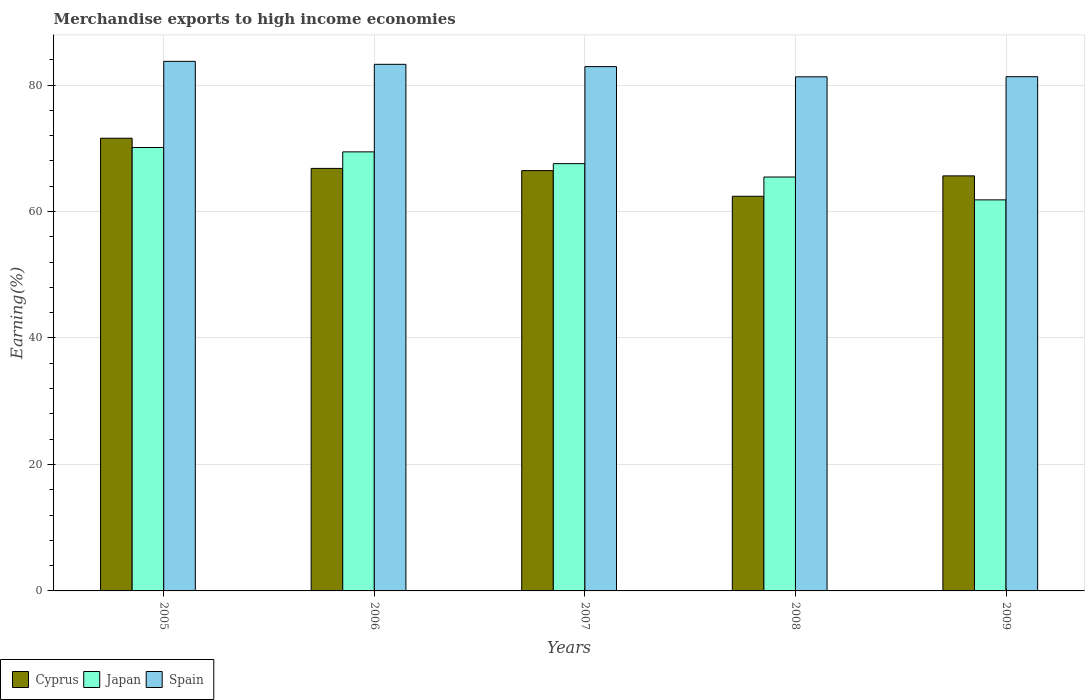How many different coloured bars are there?
Keep it short and to the point. 3. How many groups of bars are there?
Provide a short and direct response. 5. Are the number of bars per tick equal to the number of legend labels?
Ensure brevity in your answer.  Yes. Are the number of bars on each tick of the X-axis equal?
Offer a very short reply. Yes. How many bars are there on the 1st tick from the left?
Your answer should be very brief. 3. What is the label of the 2nd group of bars from the left?
Offer a terse response. 2006. What is the percentage of amount earned from merchandise exports in Spain in 2007?
Make the answer very short. 82.91. Across all years, what is the maximum percentage of amount earned from merchandise exports in Spain?
Provide a short and direct response. 83.74. Across all years, what is the minimum percentage of amount earned from merchandise exports in Cyprus?
Offer a very short reply. 62.4. What is the total percentage of amount earned from merchandise exports in Cyprus in the graph?
Make the answer very short. 332.9. What is the difference between the percentage of amount earned from merchandise exports in Japan in 2007 and that in 2008?
Provide a succinct answer. 2.12. What is the difference between the percentage of amount earned from merchandise exports in Cyprus in 2008 and the percentage of amount earned from merchandise exports in Japan in 2007?
Your answer should be compact. -5.16. What is the average percentage of amount earned from merchandise exports in Cyprus per year?
Give a very brief answer. 66.58. In the year 2009, what is the difference between the percentage of amount earned from merchandise exports in Japan and percentage of amount earned from merchandise exports in Spain?
Offer a terse response. -19.48. What is the ratio of the percentage of amount earned from merchandise exports in Cyprus in 2008 to that in 2009?
Your answer should be compact. 0.95. Is the difference between the percentage of amount earned from merchandise exports in Japan in 2008 and 2009 greater than the difference between the percentage of amount earned from merchandise exports in Spain in 2008 and 2009?
Ensure brevity in your answer.  Yes. What is the difference between the highest and the second highest percentage of amount earned from merchandise exports in Cyprus?
Your response must be concise. 4.77. What is the difference between the highest and the lowest percentage of amount earned from merchandise exports in Japan?
Keep it short and to the point. 8.28. In how many years, is the percentage of amount earned from merchandise exports in Spain greater than the average percentage of amount earned from merchandise exports in Spain taken over all years?
Your answer should be compact. 3. What does the 1st bar from the left in 2009 represents?
Offer a terse response. Cyprus. Is it the case that in every year, the sum of the percentage of amount earned from merchandise exports in Japan and percentage of amount earned from merchandise exports in Cyprus is greater than the percentage of amount earned from merchandise exports in Spain?
Offer a very short reply. Yes. How many bars are there?
Make the answer very short. 15. Are all the bars in the graph horizontal?
Provide a succinct answer. No. How many years are there in the graph?
Give a very brief answer. 5. What is the difference between two consecutive major ticks on the Y-axis?
Keep it short and to the point. 20. Are the values on the major ticks of Y-axis written in scientific E-notation?
Give a very brief answer. No. Does the graph contain any zero values?
Offer a terse response. No. Does the graph contain grids?
Make the answer very short. Yes. Where does the legend appear in the graph?
Provide a succinct answer. Bottom left. How are the legend labels stacked?
Your answer should be compact. Horizontal. What is the title of the graph?
Keep it short and to the point. Merchandise exports to high income economies. What is the label or title of the Y-axis?
Make the answer very short. Earning(%). What is the Earning(%) of Cyprus in 2005?
Provide a short and direct response. 71.59. What is the Earning(%) of Japan in 2005?
Provide a succinct answer. 70.12. What is the Earning(%) in Spain in 2005?
Your answer should be compact. 83.74. What is the Earning(%) of Cyprus in 2006?
Ensure brevity in your answer.  66.81. What is the Earning(%) of Japan in 2006?
Your answer should be compact. 69.43. What is the Earning(%) of Spain in 2006?
Ensure brevity in your answer.  83.27. What is the Earning(%) in Cyprus in 2007?
Give a very brief answer. 66.46. What is the Earning(%) in Japan in 2007?
Make the answer very short. 67.57. What is the Earning(%) in Spain in 2007?
Offer a very short reply. 82.91. What is the Earning(%) in Cyprus in 2008?
Your response must be concise. 62.4. What is the Earning(%) of Japan in 2008?
Provide a succinct answer. 65.45. What is the Earning(%) in Spain in 2008?
Ensure brevity in your answer.  81.3. What is the Earning(%) in Cyprus in 2009?
Your answer should be compact. 65.63. What is the Earning(%) in Japan in 2009?
Keep it short and to the point. 61.84. What is the Earning(%) of Spain in 2009?
Make the answer very short. 81.31. Across all years, what is the maximum Earning(%) in Cyprus?
Offer a terse response. 71.59. Across all years, what is the maximum Earning(%) of Japan?
Your response must be concise. 70.12. Across all years, what is the maximum Earning(%) in Spain?
Ensure brevity in your answer.  83.74. Across all years, what is the minimum Earning(%) of Cyprus?
Make the answer very short. 62.4. Across all years, what is the minimum Earning(%) of Japan?
Offer a terse response. 61.84. Across all years, what is the minimum Earning(%) in Spain?
Provide a short and direct response. 81.3. What is the total Earning(%) in Cyprus in the graph?
Keep it short and to the point. 332.9. What is the total Earning(%) in Japan in the graph?
Offer a very short reply. 334.4. What is the total Earning(%) of Spain in the graph?
Offer a terse response. 412.53. What is the difference between the Earning(%) of Cyprus in 2005 and that in 2006?
Your response must be concise. 4.77. What is the difference between the Earning(%) of Japan in 2005 and that in 2006?
Your response must be concise. 0.69. What is the difference between the Earning(%) of Spain in 2005 and that in 2006?
Your response must be concise. 0.47. What is the difference between the Earning(%) of Cyprus in 2005 and that in 2007?
Provide a succinct answer. 5.12. What is the difference between the Earning(%) in Japan in 2005 and that in 2007?
Offer a terse response. 2.55. What is the difference between the Earning(%) in Spain in 2005 and that in 2007?
Your answer should be compact. 0.83. What is the difference between the Earning(%) in Cyprus in 2005 and that in 2008?
Provide a short and direct response. 9.18. What is the difference between the Earning(%) of Japan in 2005 and that in 2008?
Make the answer very short. 4.67. What is the difference between the Earning(%) of Spain in 2005 and that in 2008?
Give a very brief answer. 2.44. What is the difference between the Earning(%) of Cyprus in 2005 and that in 2009?
Your response must be concise. 5.96. What is the difference between the Earning(%) of Japan in 2005 and that in 2009?
Keep it short and to the point. 8.28. What is the difference between the Earning(%) of Spain in 2005 and that in 2009?
Offer a terse response. 2.43. What is the difference between the Earning(%) in Cyprus in 2006 and that in 2007?
Your answer should be very brief. 0.35. What is the difference between the Earning(%) of Japan in 2006 and that in 2007?
Offer a very short reply. 1.86. What is the difference between the Earning(%) of Spain in 2006 and that in 2007?
Offer a terse response. 0.36. What is the difference between the Earning(%) of Cyprus in 2006 and that in 2008?
Make the answer very short. 4.41. What is the difference between the Earning(%) in Japan in 2006 and that in 2008?
Provide a short and direct response. 3.98. What is the difference between the Earning(%) in Spain in 2006 and that in 2008?
Ensure brevity in your answer.  1.98. What is the difference between the Earning(%) in Cyprus in 2006 and that in 2009?
Your response must be concise. 1.18. What is the difference between the Earning(%) in Japan in 2006 and that in 2009?
Offer a terse response. 7.59. What is the difference between the Earning(%) in Spain in 2006 and that in 2009?
Your response must be concise. 1.96. What is the difference between the Earning(%) in Cyprus in 2007 and that in 2008?
Provide a short and direct response. 4.06. What is the difference between the Earning(%) in Japan in 2007 and that in 2008?
Your answer should be very brief. 2.12. What is the difference between the Earning(%) of Spain in 2007 and that in 2008?
Keep it short and to the point. 1.61. What is the difference between the Earning(%) of Cyprus in 2007 and that in 2009?
Provide a succinct answer. 0.83. What is the difference between the Earning(%) in Japan in 2007 and that in 2009?
Your answer should be compact. 5.73. What is the difference between the Earning(%) of Spain in 2007 and that in 2009?
Your response must be concise. 1.59. What is the difference between the Earning(%) of Cyprus in 2008 and that in 2009?
Give a very brief answer. -3.23. What is the difference between the Earning(%) in Japan in 2008 and that in 2009?
Offer a terse response. 3.61. What is the difference between the Earning(%) in Spain in 2008 and that in 2009?
Make the answer very short. -0.02. What is the difference between the Earning(%) of Cyprus in 2005 and the Earning(%) of Japan in 2006?
Ensure brevity in your answer.  2.16. What is the difference between the Earning(%) in Cyprus in 2005 and the Earning(%) in Spain in 2006?
Your response must be concise. -11.69. What is the difference between the Earning(%) in Japan in 2005 and the Earning(%) in Spain in 2006?
Offer a very short reply. -13.15. What is the difference between the Earning(%) in Cyprus in 2005 and the Earning(%) in Japan in 2007?
Your answer should be compact. 4.02. What is the difference between the Earning(%) in Cyprus in 2005 and the Earning(%) in Spain in 2007?
Provide a succinct answer. -11.32. What is the difference between the Earning(%) in Japan in 2005 and the Earning(%) in Spain in 2007?
Keep it short and to the point. -12.79. What is the difference between the Earning(%) of Cyprus in 2005 and the Earning(%) of Japan in 2008?
Your answer should be compact. 6.14. What is the difference between the Earning(%) of Cyprus in 2005 and the Earning(%) of Spain in 2008?
Give a very brief answer. -9.71. What is the difference between the Earning(%) of Japan in 2005 and the Earning(%) of Spain in 2008?
Provide a short and direct response. -11.18. What is the difference between the Earning(%) in Cyprus in 2005 and the Earning(%) in Japan in 2009?
Offer a very short reply. 9.75. What is the difference between the Earning(%) in Cyprus in 2005 and the Earning(%) in Spain in 2009?
Your answer should be compact. -9.73. What is the difference between the Earning(%) of Japan in 2005 and the Earning(%) of Spain in 2009?
Provide a short and direct response. -11.2. What is the difference between the Earning(%) in Cyprus in 2006 and the Earning(%) in Japan in 2007?
Provide a short and direct response. -0.75. What is the difference between the Earning(%) in Cyprus in 2006 and the Earning(%) in Spain in 2007?
Offer a terse response. -16.09. What is the difference between the Earning(%) in Japan in 2006 and the Earning(%) in Spain in 2007?
Offer a terse response. -13.48. What is the difference between the Earning(%) of Cyprus in 2006 and the Earning(%) of Japan in 2008?
Offer a very short reply. 1.37. What is the difference between the Earning(%) in Cyprus in 2006 and the Earning(%) in Spain in 2008?
Ensure brevity in your answer.  -14.48. What is the difference between the Earning(%) in Japan in 2006 and the Earning(%) in Spain in 2008?
Offer a very short reply. -11.87. What is the difference between the Earning(%) of Cyprus in 2006 and the Earning(%) of Japan in 2009?
Your answer should be compact. 4.98. What is the difference between the Earning(%) in Cyprus in 2006 and the Earning(%) in Spain in 2009?
Your answer should be very brief. -14.5. What is the difference between the Earning(%) in Japan in 2006 and the Earning(%) in Spain in 2009?
Offer a very short reply. -11.89. What is the difference between the Earning(%) in Cyprus in 2007 and the Earning(%) in Japan in 2008?
Provide a succinct answer. 1.01. What is the difference between the Earning(%) of Cyprus in 2007 and the Earning(%) of Spain in 2008?
Provide a short and direct response. -14.83. What is the difference between the Earning(%) in Japan in 2007 and the Earning(%) in Spain in 2008?
Offer a terse response. -13.73. What is the difference between the Earning(%) of Cyprus in 2007 and the Earning(%) of Japan in 2009?
Ensure brevity in your answer.  4.62. What is the difference between the Earning(%) of Cyprus in 2007 and the Earning(%) of Spain in 2009?
Provide a succinct answer. -14.85. What is the difference between the Earning(%) of Japan in 2007 and the Earning(%) of Spain in 2009?
Give a very brief answer. -13.75. What is the difference between the Earning(%) in Cyprus in 2008 and the Earning(%) in Japan in 2009?
Provide a short and direct response. 0.57. What is the difference between the Earning(%) of Cyprus in 2008 and the Earning(%) of Spain in 2009?
Provide a short and direct response. -18.91. What is the difference between the Earning(%) of Japan in 2008 and the Earning(%) of Spain in 2009?
Your answer should be compact. -15.86. What is the average Earning(%) in Cyprus per year?
Ensure brevity in your answer.  66.58. What is the average Earning(%) in Japan per year?
Offer a terse response. 66.88. What is the average Earning(%) in Spain per year?
Keep it short and to the point. 82.51. In the year 2005, what is the difference between the Earning(%) of Cyprus and Earning(%) of Japan?
Give a very brief answer. 1.47. In the year 2005, what is the difference between the Earning(%) of Cyprus and Earning(%) of Spain?
Provide a short and direct response. -12.15. In the year 2005, what is the difference between the Earning(%) of Japan and Earning(%) of Spain?
Make the answer very short. -13.62. In the year 2006, what is the difference between the Earning(%) of Cyprus and Earning(%) of Japan?
Give a very brief answer. -2.61. In the year 2006, what is the difference between the Earning(%) of Cyprus and Earning(%) of Spain?
Your answer should be compact. -16.46. In the year 2006, what is the difference between the Earning(%) of Japan and Earning(%) of Spain?
Offer a very short reply. -13.84. In the year 2007, what is the difference between the Earning(%) of Cyprus and Earning(%) of Japan?
Give a very brief answer. -1.1. In the year 2007, what is the difference between the Earning(%) of Cyprus and Earning(%) of Spain?
Make the answer very short. -16.45. In the year 2007, what is the difference between the Earning(%) of Japan and Earning(%) of Spain?
Provide a succinct answer. -15.34. In the year 2008, what is the difference between the Earning(%) in Cyprus and Earning(%) in Japan?
Your answer should be compact. -3.04. In the year 2008, what is the difference between the Earning(%) in Cyprus and Earning(%) in Spain?
Provide a succinct answer. -18.89. In the year 2008, what is the difference between the Earning(%) of Japan and Earning(%) of Spain?
Provide a short and direct response. -15.85. In the year 2009, what is the difference between the Earning(%) in Cyprus and Earning(%) in Japan?
Keep it short and to the point. 3.79. In the year 2009, what is the difference between the Earning(%) of Cyprus and Earning(%) of Spain?
Your response must be concise. -15.68. In the year 2009, what is the difference between the Earning(%) of Japan and Earning(%) of Spain?
Your answer should be very brief. -19.48. What is the ratio of the Earning(%) in Cyprus in 2005 to that in 2006?
Make the answer very short. 1.07. What is the ratio of the Earning(%) in Japan in 2005 to that in 2006?
Your answer should be very brief. 1.01. What is the ratio of the Earning(%) of Spain in 2005 to that in 2006?
Offer a very short reply. 1.01. What is the ratio of the Earning(%) of Cyprus in 2005 to that in 2007?
Provide a succinct answer. 1.08. What is the ratio of the Earning(%) of Japan in 2005 to that in 2007?
Provide a succinct answer. 1.04. What is the ratio of the Earning(%) in Cyprus in 2005 to that in 2008?
Your answer should be very brief. 1.15. What is the ratio of the Earning(%) of Japan in 2005 to that in 2008?
Keep it short and to the point. 1.07. What is the ratio of the Earning(%) of Spain in 2005 to that in 2008?
Offer a very short reply. 1.03. What is the ratio of the Earning(%) in Cyprus in 2005 to that in 2009?
Your response must be concise. 1.09. What is the ratio of the Earning(%) in Japan in 2005 to that in 2009?
Keep it short and to the point. 1.13. What is the ratio of the Earning(%) in Spain in 2005 to that in 2009?
Offer a very short reply. 1.03. What is the ratio of the Earning(%) of Cyprus in 2006 to that in 2007?
Offer a very short reply. 1.01. What is the ratio of the Earning(%) in Japan in 2006 to that in 2007?
Your response must be concise. 1.03. What is the ratio of the Earning(%) of Spain in 2006 to that in 2007?
Your answer should be very brief. 1. What is the ratio of the Earning(%) in Cyprus in 2006 to that in 2008?
Ensure brevity in your answer.  1.07. What is the ratio of the Earning(%) in Japan in 2006 to that in 2008?
Give a very brief answer. 1.06. What is the ratio of the Earning(%) in Spain in 2006 to that in 2008?
Provide a succinct answer. 1.02. What is the ratio of the Earning(%) of Cyprus in 2006 to that in 2009?
Ensure brevity in your answer.  1.02. What is the ratio of the Earning(%) of Japan in 2006 to that in 2009?
Your answer should be very brief. 1.12. What is the ratio of the Earning(%) in Spain in 2006 to that in 2009?
Provide a short and direct response. 1.02. What is the ratio of the Earning(%) of Cyprus in 2007 to that in 2008?
Your answer should be very brief. 1.06. What is the ratio of the Earning(%) in Japan in 2007 to that in 2008?
Provide a short and direct response. 1.03. What is the ratio of the Earning(%) in Spain in 2007 to that in 2008?
Provide a short and direct response. 1.02. What is the ratio of the Earning(%) in Cyprus in 2007 to that in 2009?
Your response must be concise. 1.01. What is the ratio of the Earning(%) of Japan in 2007 to that in 2009?
Make the answer very short. 1.09. What is the ratio of the Earning(%) of Spain in 2007 to that in 2009?
Your answer should be very brief. 1.02. What is the ratio of the Earning(%) of Cyprus in 2008 to that in 2009?
Give a very brief answer. 0.95. What is the ratio of the Earning(%) of Japan in 2008 to that in 2009?
Make the answer very short. 1.06. What is the ratio of the Earning(%) of Spain in 2008 to that in 2009?
Offer a very short reply. 1. What is the difference between the highest and the second highest Earning(%) of Cyprus?
Provide a succinct answer. 4.77. What is the difference between the highest and the second highest Earning(%) of Japan?
Ensure brevity in your answer.  0.69. What is the difference between the highest and the second highest Earning(%) of Spain?
Your answer should be very brief. 0.47. What is the difference between the highest and the lowest Earning(%) in Cyprus?
Offer a very short reply. 9.18. What is the difference between the highest and the lowest Earning(%) in Japan?
Your response must be concise. 8.28. What is the difference between the highest and the lowest Earning(%) of Spain?
Your response must be concise. 2.44. 